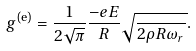Convert formula to latex. <formula><loc_0><loc_0><loc_500><loc_500>g ^ { \text {(e)} } = \frac { 1 } { 2 \sqrt { \pi } } \frac { - e E } { R } \sqrt { \frac { } { 2 \rho R \omega _ { r } } } .</formula> 